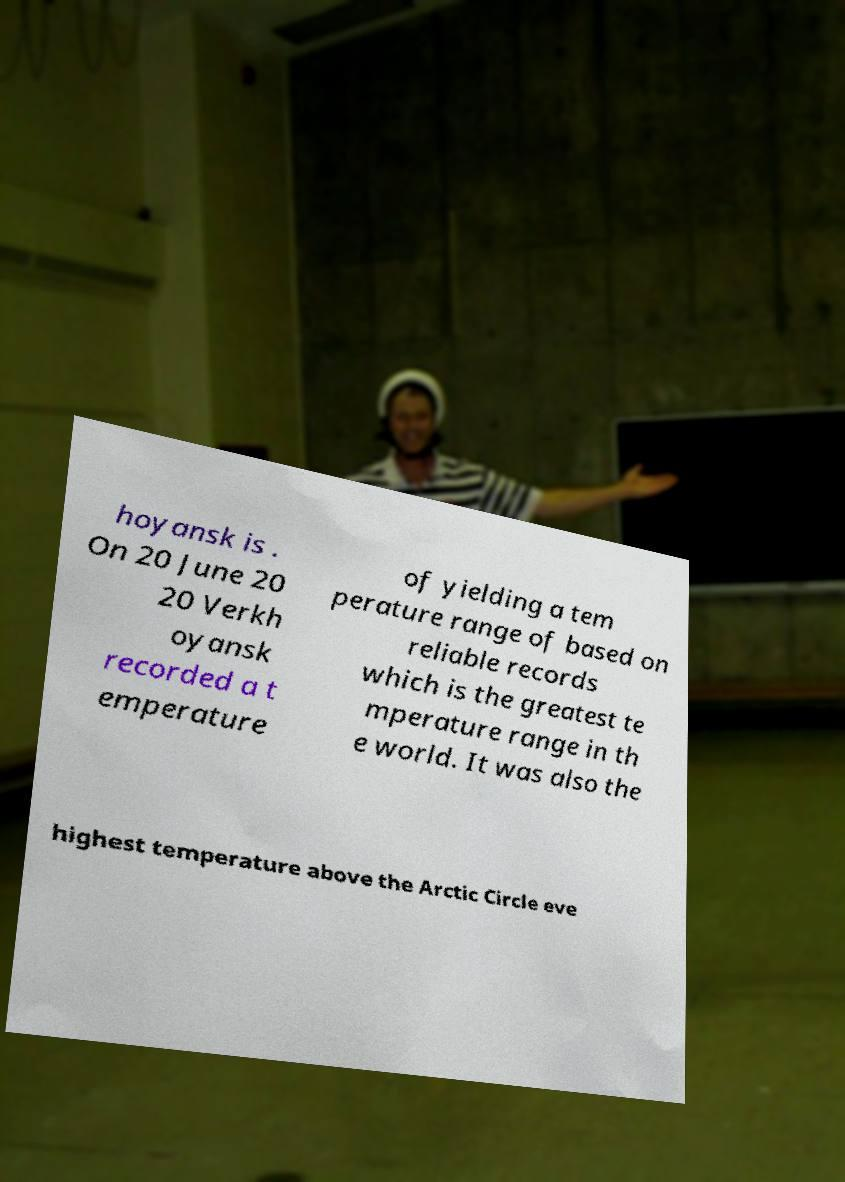What messages or text are displayed in this image? I need them in a readable, typed format. hoyansk is . On 20 June 20 20 Verkh oyansk recorded a t emperature of yielding a tem perature range of based on reliable records which is the greatest te mperature range in th e world. It was also the highest temperature above the Arctic Circle eve 